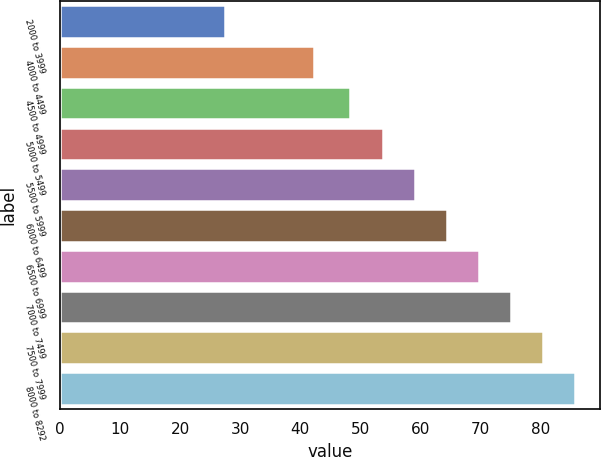Convert chart. <chart><loc_0><loc_0><loc_500><loc_500><bar_chart><fcel>2000 to 3999<fcel>4000 to 4499<fcel>4500 to 4999<fcel>5000 to 5499<fcel>5500 to 5999<fcel>6000 to 6499<fcel>6500 to 6999<fcel>7000 to 7499<fcel>7500 to 7999<fcel>8000 to 8292<nl><fcel>27.44<fcel>42.23<fcel>48.3<fcel>53.71<fcel>59.03<fcel>64.35<fcel>69.67<fcel>74.99<fcel>80.31<fcel>85.63<nl></chart> 